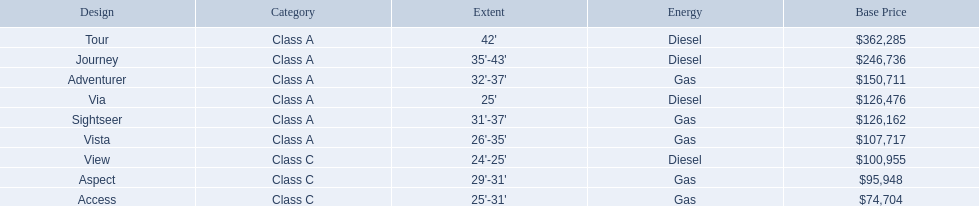Which of the models in the table use diesel fuel? Tour, Journey, Via, View. Of these models, which are class a? Tour, Journey, Via. Which of them are greater than 35' in length? Tour, Journey. Which of the two models is more expensive? Tour. What are the prices? $362,285, $246,736, $150,711, $126,476, $126,162, $107,717, $100,955, $95,948, $74,704. What is the top price? $362,285. What model has this price? Tour. 